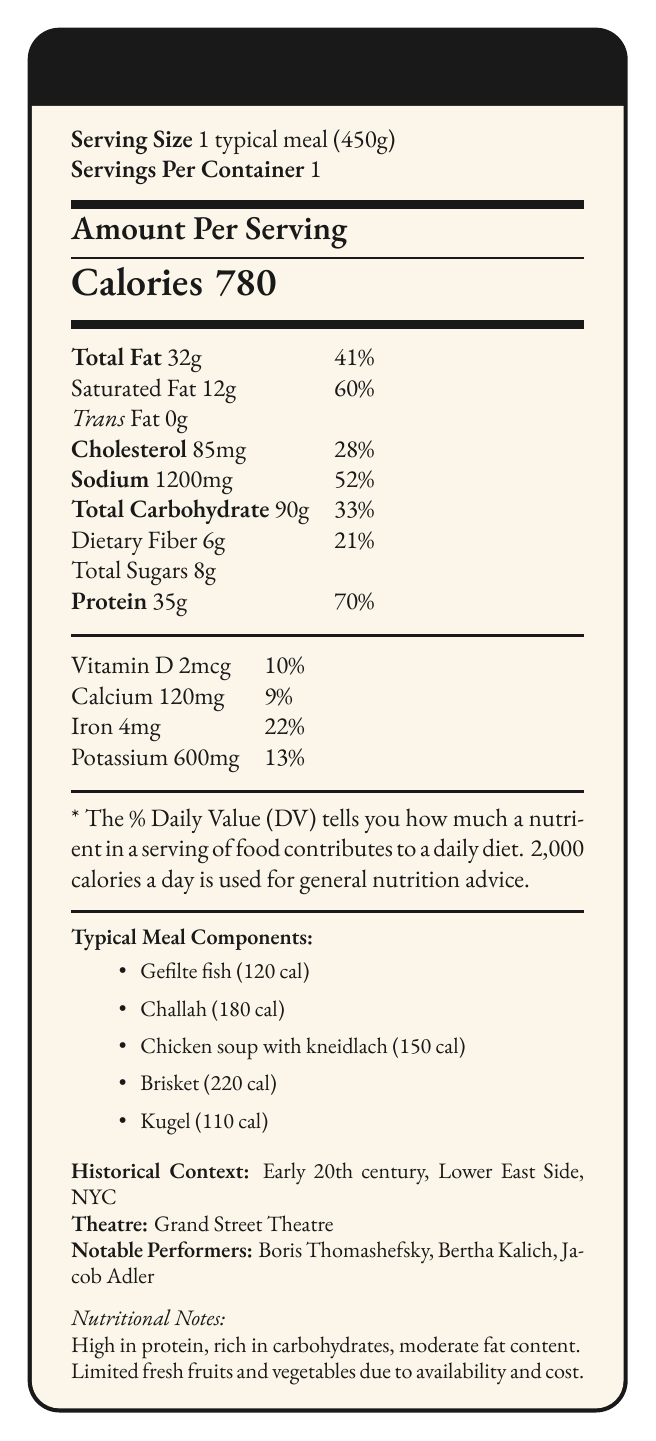what is the serving size of a typical meal? The document clearly states that the serving size is 1 typical meal weighing 450 grams.
Answer: 1 typical meal (450g) how many calories are in a typical meal? The number of calories is prominently displayed under "Amount Per Serving" as 780.
Answer: 780 what components make up the typical meal consumed by Yiddish theatre performers? The document lists these components under the "Typical Meal Components" section.
Answer: Gefilte fish, Challah, Chicken soup with kneidlach, Brisket, Kugel what percentage of the daily value for protein does one typical meal provide? The percentage for protein is listed as 70% in the document.
Answer: 70% what are the amounts of calcium and iron in a typical meal? These amounts are listed under the "Vitamin D, Calcium, Iron, Potassium" section.
Answer: Calcium: 120 mg, Iron: 4 mg how much saturated fat is in one typical meal? The amount of saturated fat is 12 grams, as shown in the document.
Answer: 12g which meal component has the highest calorie content? 
A. Gefilte fish
B. Challah
C. Chicken soup with kneidlach
D. Brisket
E. Kugel Brisket has the highest calorie content at 220 calories, as listed in the "Typical Meal Components" section.
Answer: D. Brisket what type of cuisine influenced the diet of Yiddish theatre performers? 
i. American fast food
ii. Eastern European Jewish cuisine
iii. French cuisine The document mentions that the dietary influences include Eastern European Jewish cuisine.
Answer: ii. Eastern European Jewish cuisine does the document state the amount of vitamins A and C in the meal? The document does not mention the amounts of vitamins A and C.
Answer: No is the total fat content in the meal within the daily recommended limit? The total fat is 32g, which is 41% of the daily value. This is within the general daily limit when considering a 2,000 calorie diet.
Answer: Yes describe the main nutritional characteristics of the typical meal consumed by Yiddish theatre performers in the early 20th century This summary captures the key nutritional elements, meal components, and historical context detailed in the document.
Answer: The meal is high in protein and carbohydrates, has moderate fat content, and is influenced by Eastern European Jewish cuisine. It includes components like gefilte fish, challah, chicken soup with kneidlach, brisket, and kugel. Nutritional notes highlight support for long rehearsal hours, with limitations in fresh fruits and vegetables. which notable performer is not listed among the important figures in Yiddish theatre? 
A. Boris Thomashefsky
B. Bertha Kalich
C. Jacob Adler
D. Stella Adler Stella Adler is not listed among the notable performers; the document lists Boris Thomashefsky, Bertha Kalich, and Jacob Adler.
Answer: D. Stella Adler how much dietary fiber is in the meal? The amount of dietary fiber is listed as 6 grams in the document.
Answer: 6g why was the intake of fresh fruits and vegetables limited in the diet of Yiddish theatre performers? The document mentions that fresh fruits and vegetables were limited due to seasonal availability and cost.
Answer: Limited availability and cost who were some of the notable performers at the Grand Street Theatre? These performers are mentioned as notable figures in the historical context section.
Answer: Boris Thomashefsky, Bertha Kalich, Jacob Adler 